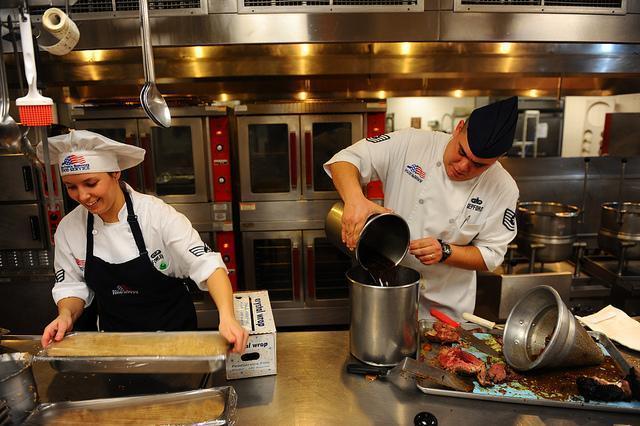How many ovens are in the picture?
Give a very brief answer. 3. How many people can you see?
Give a very brief answer. 2. 